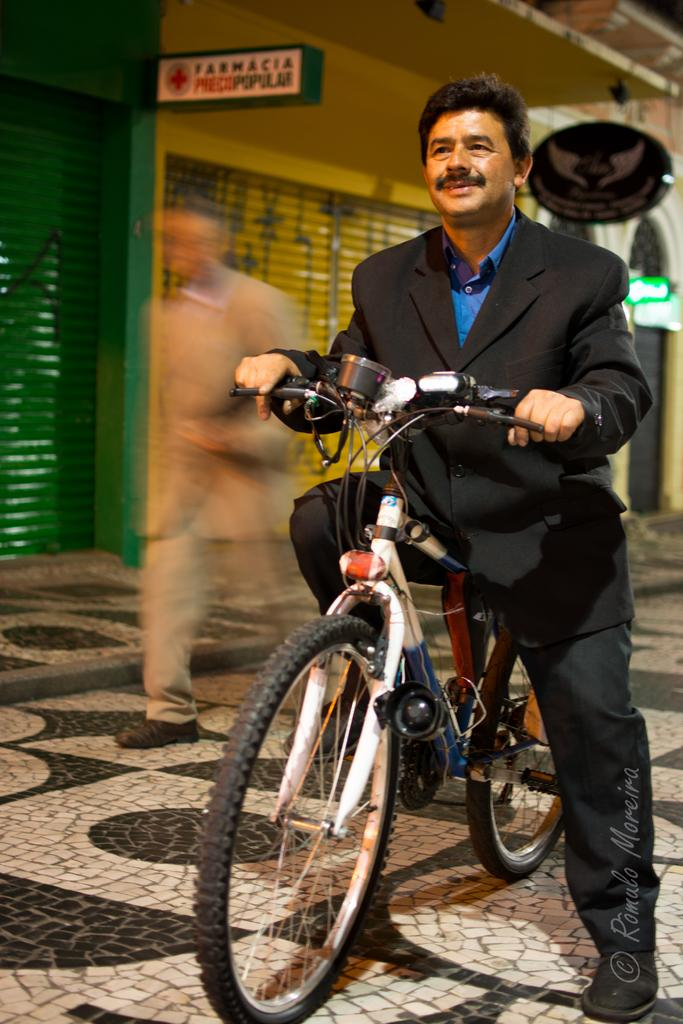What is the main subject of the image? There is a person in the image. What is the person doing in the image? The person is riding a bicycle. What can be seen in the background of the image? There is a building in the background of the image. What type of ticket is the person holding while riding the bicycle in the image? There is no ticket present in the image; the person is simply riding a bicycle. 